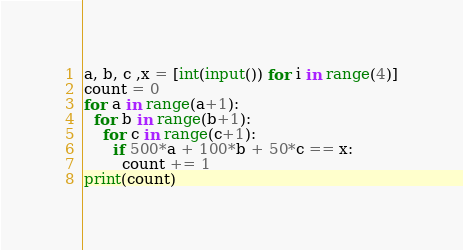Convert code to text. <code><loc_0><loc_0><loc_500><loc_500><_Python_>a, b, c ,x = [int(input()) for i in range(4)]
count = 0
for a in range(a+1):
  for b in range(b+1):
    for c in range(c+1):
      if 500*a + 100*b + 50*c == x:
        count += 1
print(count)</code> 